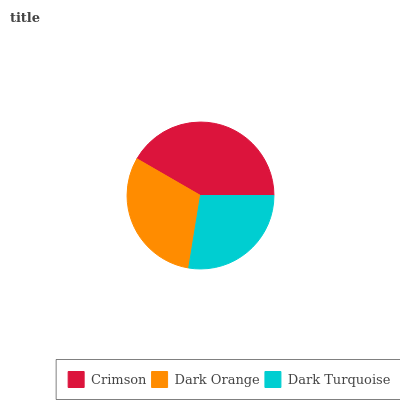Is Dark Turquoise the minimum?
Answer yes or no. Yes. Is Crimson the maximum?
Answer yes or no. Yes. Is Dark Orange the minimum?
Answer yes or no. No. Is Dark Orange the maximum?
Answer yes or no. No. Is Crimson greater than Dark Orange?
Answer yes or no. Yes. Is Dark Orange less than Crimson?
Answer yes or no. Yes. Is Dark Orange greater than Crimson?
Answer yes or no. No. Is Crimson less than Dark Orange?
Answer yes or no. No. Is Dark Orange the high median?
Answer yes or no. Yes. Is Dark Orange the low median?
Answer yes or no. Yes. Is Dark Turquoise the high median?
Answer yes or no. No. Is Dark Turquoise the low median?
Answer yes or no. No. 